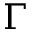<formula> <loc_0><loc_0><loc_500><loc_500>\Gamma</formula> 